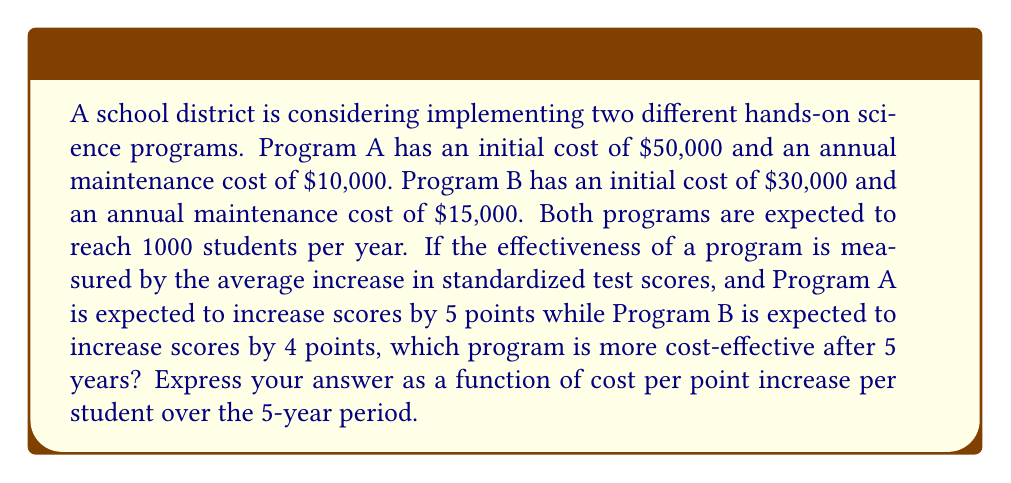Help me with this question. To solve this problem, we need to follow these steps:

1. Calculate the total cost of each program over 5 years:

   Program A: $50,000 + (5 × $10,000) = $100,000
   Program B: $30,000 + (5 × $15,000) = $105,000

2. Calculate the total number of students reached over 5 years:
   
   Both programs: 1000 students/year × 5 years = 5000 students

3. Calculate the total point increase for each program over 5 years:

   Program A: 5 points/student × 5000 students = 25,000 points
   Program B: 4 points/student × 5000 students = 20,000 points

4. Calculate the cost per point increase per student for each program:

   Program A: $\frac{\text{Total Cost}}{\text{Total Point Increase}} = \frac{100,000}{25,000} = $4 per point
   Program B: $\frac{\text{Total Cost}}{\text{Total Point Increase}} = \frac{105,000}{20,000} = $5.25 per point

5. Compare the cost-effectiveness:

   Program A costs $4 per point increase per student over 5 years.
   Program B costs $5.25 per point increase per student over 5 years.

Therefore, Program A is more cost-effective after 5 years.

To express this as a function, let:
$C_A(t)$ be the cost of Program A after t years
$C_B(t)$ be the cost of Program B after t years
$S$ be the number of students per year
$P_A$ be the point increase for Program A
$P_B$ be the point increase for Program B

Then the cost-effectiveness functions for each program are:

$$f_A(t) = \frac{C_A(t)}{S \cdot t \cdot P_A} = \frac{50000 + 10000t}{1000 \cdot t \cdot 5} = \frac{10 + 2t}{t}$$

$$f_B(t) = \frac{C_B(t)}{S \cdot t \cdot P_B} = \frac{30000 + 15000t}{1000 \cdot t \cdot 4} = \frac{7.5 + 3.75t}{t}$$

For t = 5 years:

$$f_A(5) = \frac{10 + 2(5)}{5} = 4$$

$$f_B(5) = \frac{7.5 + 3.75(5)}{5} = 5.25$$

This confirms our previous calculations.
Answer: Program A is more cost-effective after 5 years, with a cost of $4 per point increase per student, compared to $5.25 for Program B. The cost-effectiveness functions are:

Program A: $f_A(t) = \frac{10 + 2t}{t}$
Program B: $f_B(t) = \frac{7.5 + 3.75t}{t}$

where t is the number of years. 